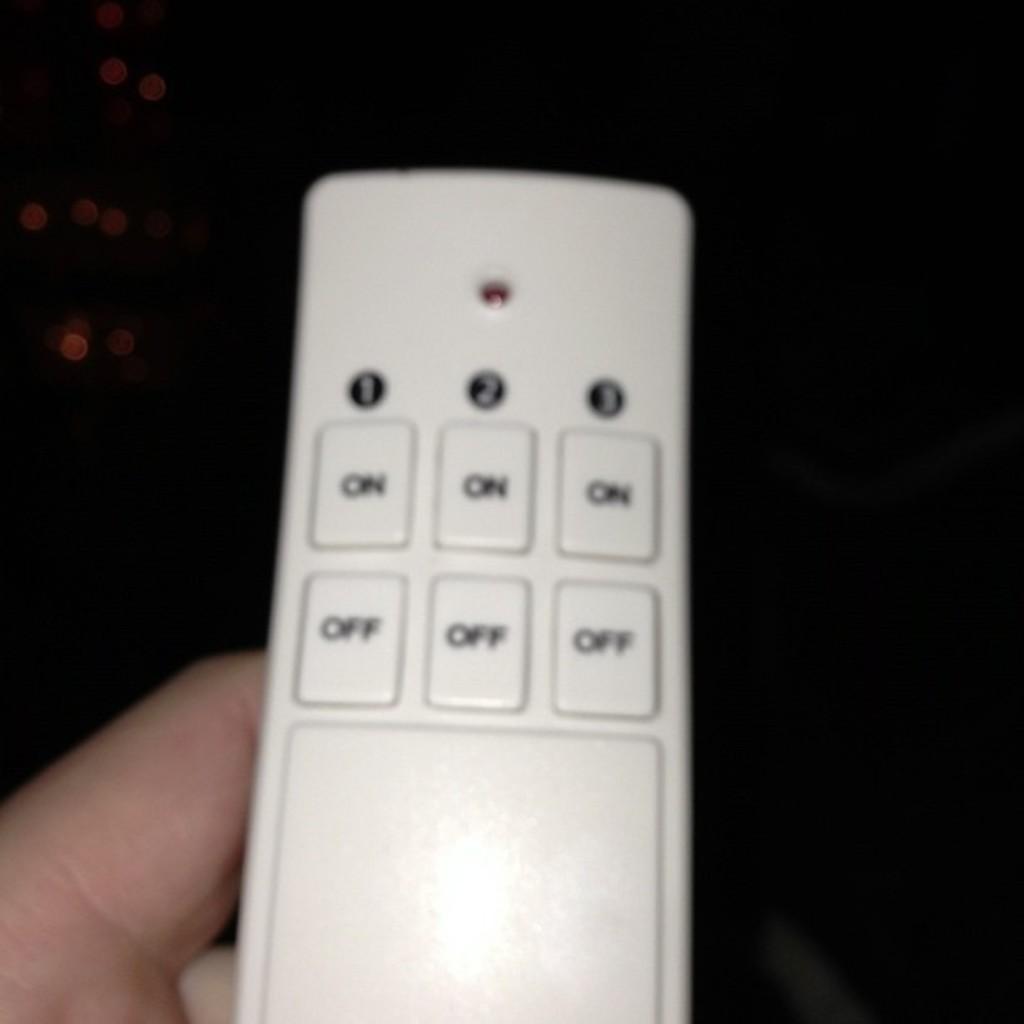What type of buttons does this have?
Provide a short and direct response. On and off. What are the numbers on top of the control?
Provide a succinct answer. 123. 